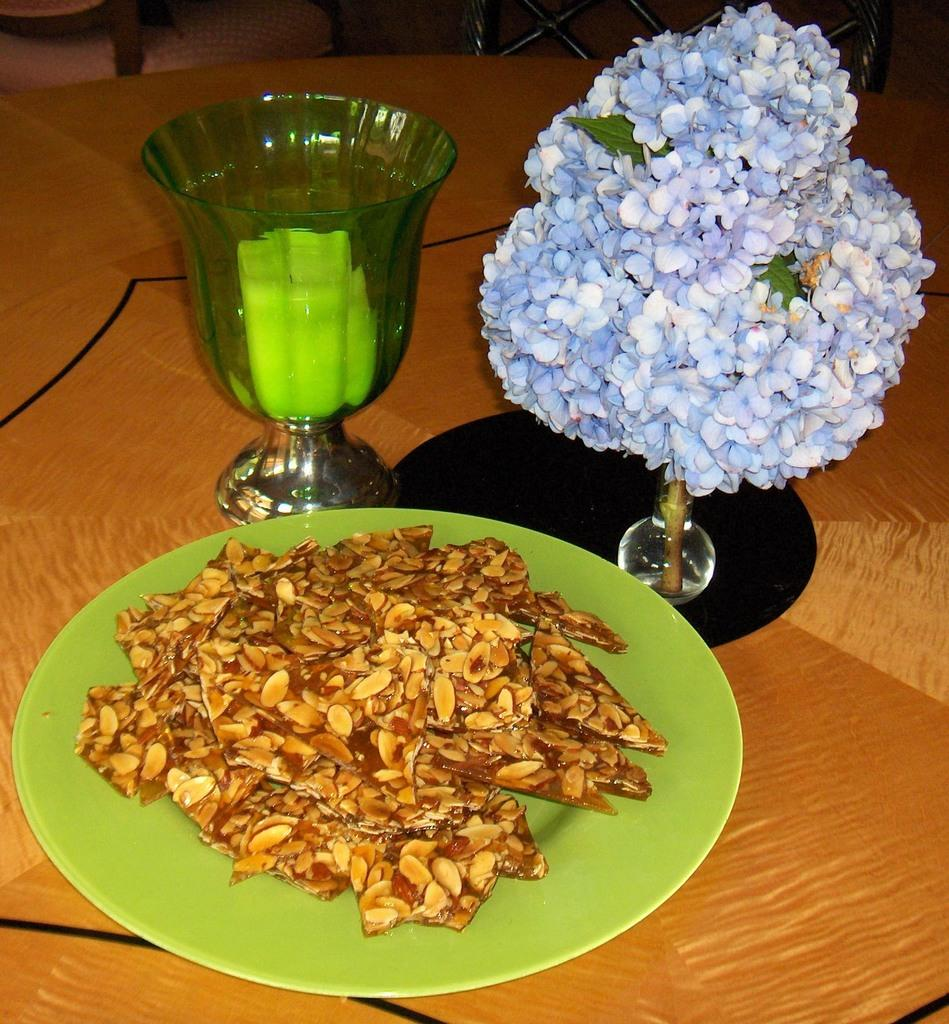What is inside the glass that is visible in the image? There is a drink in the glass that is visible in the image. What other item can be seen in the image besides the glass? There is a plate in the image. What is on the plate? There are chokes on the plate. What additional object is present on the table in the image? There is a flower book key on the table. How does the plant increase in size in the image? There is no plant present in the image, so it cannot increase in size. What type of box is visible in the image? There is no box present in the image. 